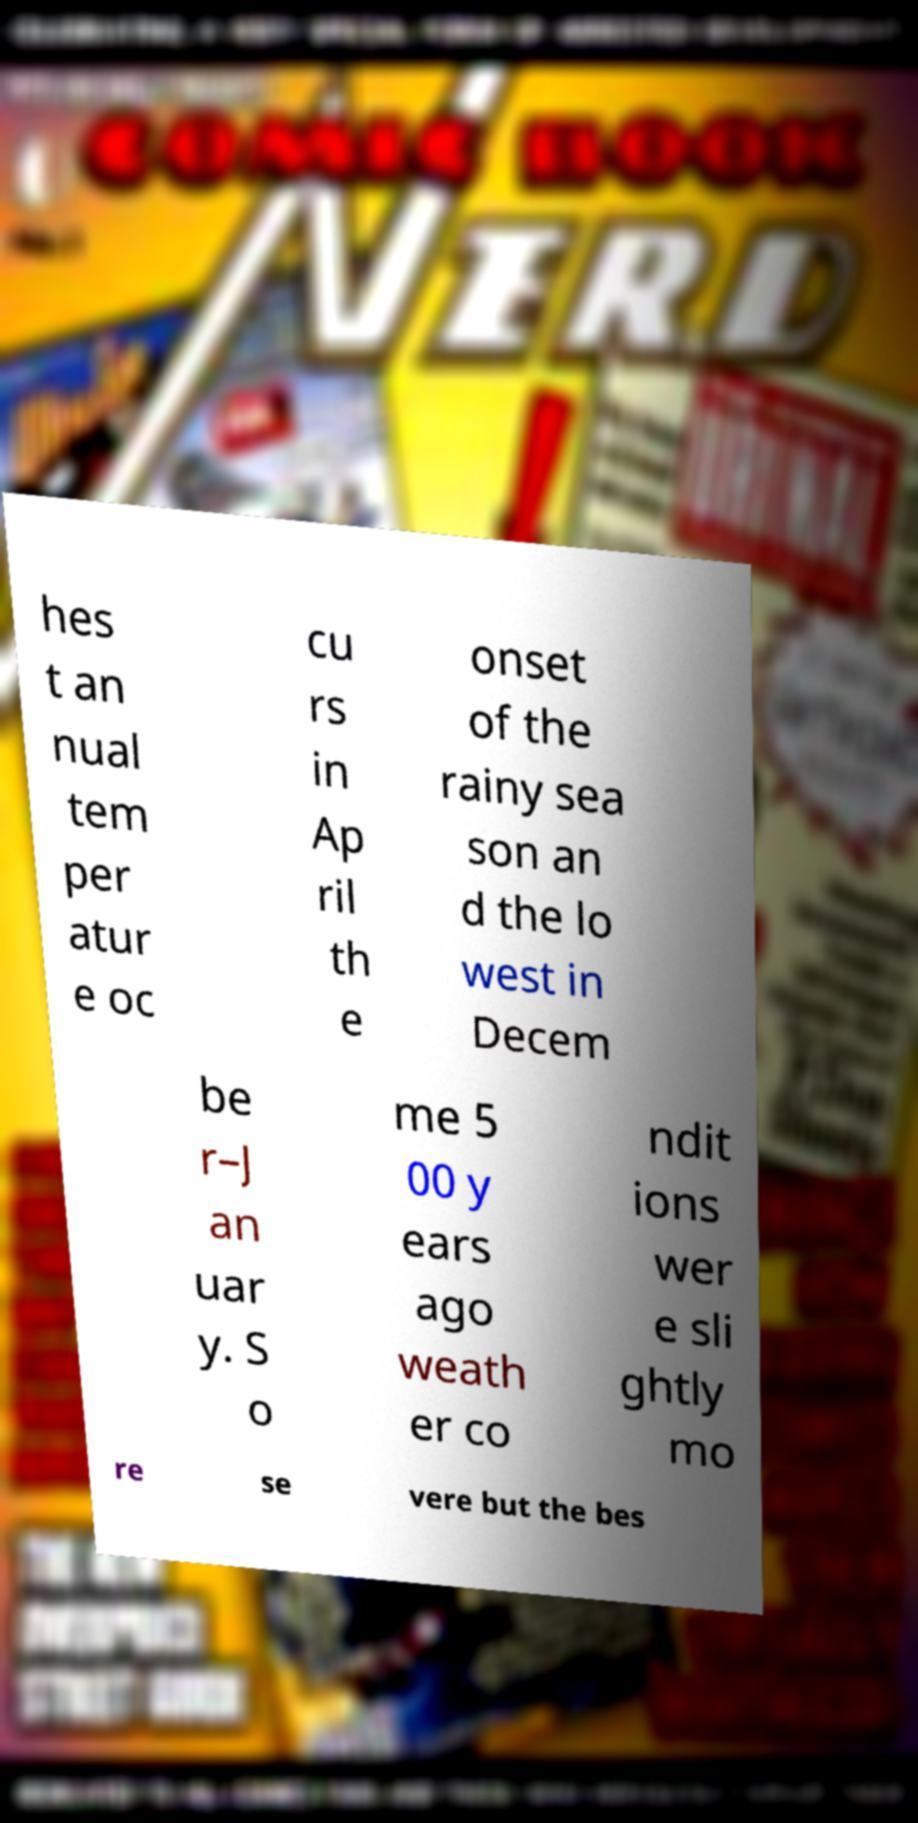Can you accurately transcribe the text from the provided image for me? hes t an nual tem per atur e oc cu rs in Ap ril th e onset of the rainy sea son an d the lo west in Decem be r–J an uar y. S o me 5 00 y ears ago weath er co ndit ions wer e sli ghtly mo re se vere but the bes 